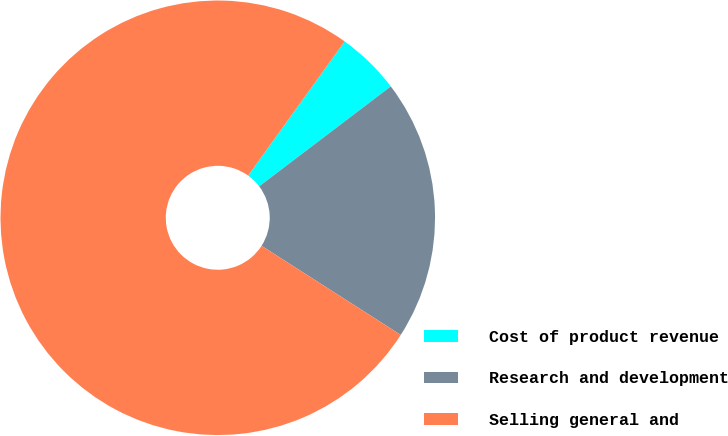Convert chart to OTSL. <chart><loc_0><loc_0><loc_500><loc_500><pie_chart><fcel>Cost of product revenue<fcel>Research and development<fcel>Selling general and<nl><fcel>4.74%<fcel>19.4%<fcel>75.87%<nl></chart> 